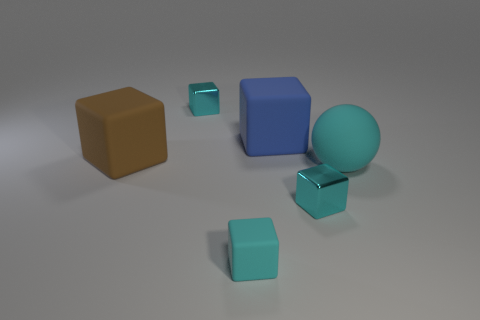Subtract all red spheres. How many cyan cubes are left? 3 Subtract 2 cubes. How many cubes are left? 3 Subtract all brown cubes. How many cubes are left? 4 Subtract all blue blocks. How many blocks are left? 4 Subtract all green blocks. Subtract all gray cylinders. How many blocks are left? 5 Add 2 small blue metal cylinders. How many objects exist? 8 Subtract all cubes. How many objects are left? 1 Add 5 big brown rubber things. How many big brown rubber things are left? 6 Add 6 green metallic cylinders. How many green metallic cylinders exist? 6 Subtract 0 cyan cylinders. How many objects are left? 6 